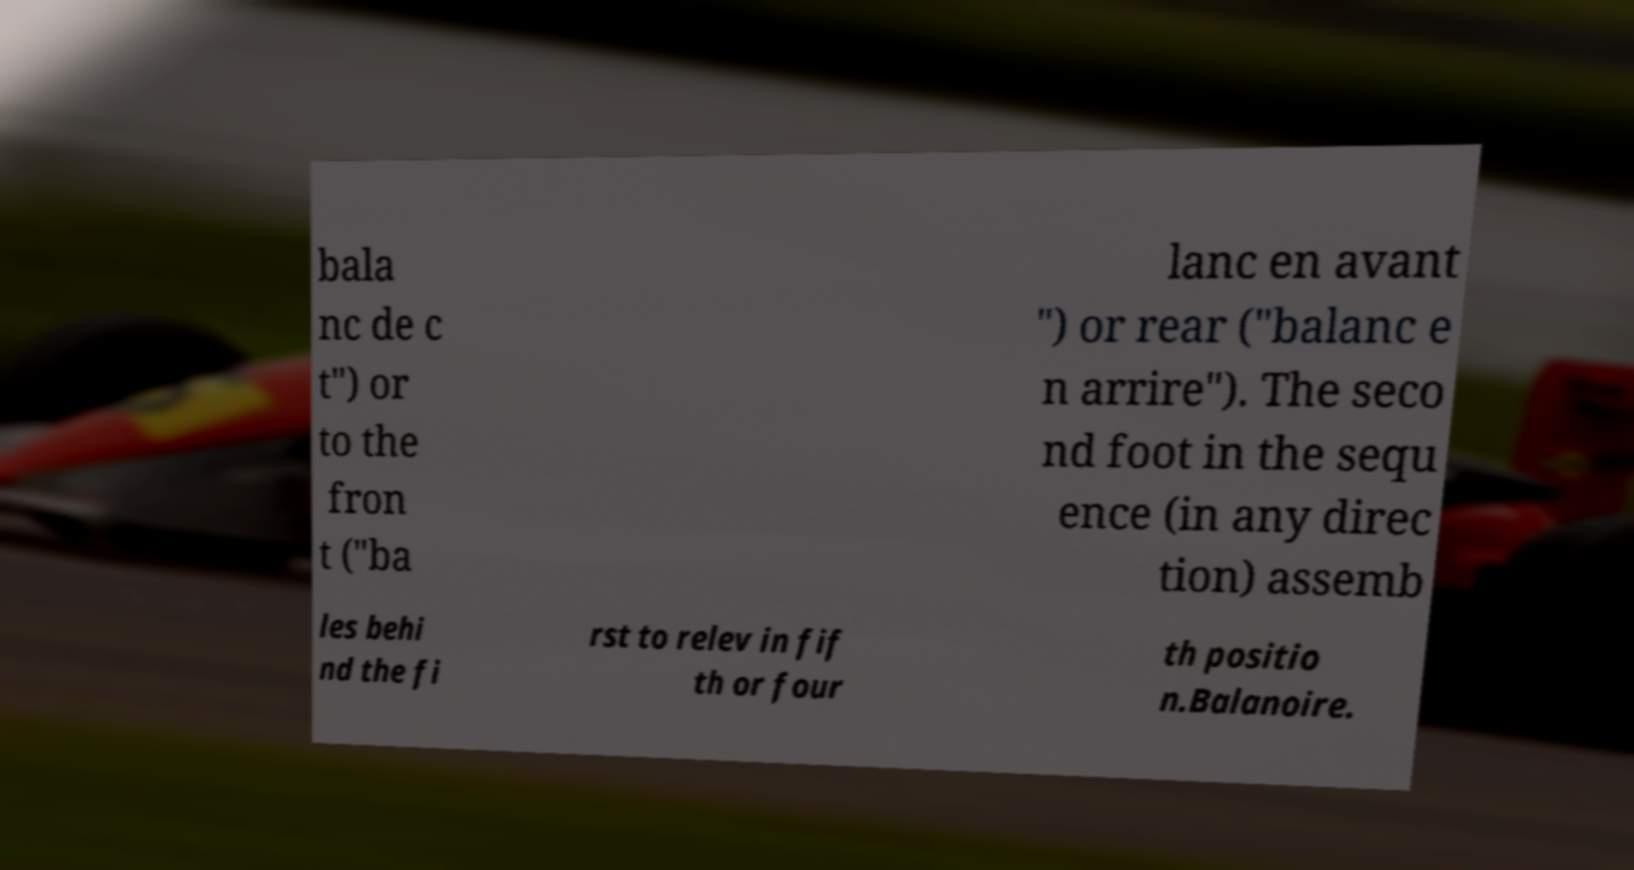Could you extract and type out the text from this image? bala nc de c t") or to the fron t ("ba lanc en avant ") or rear ("balanc e n arrire"). The seco nd foot in the sequ ence (in any direc tion) assemb les behi nd the fi rst to relev in fif th or four th positio n.Balanoire. 